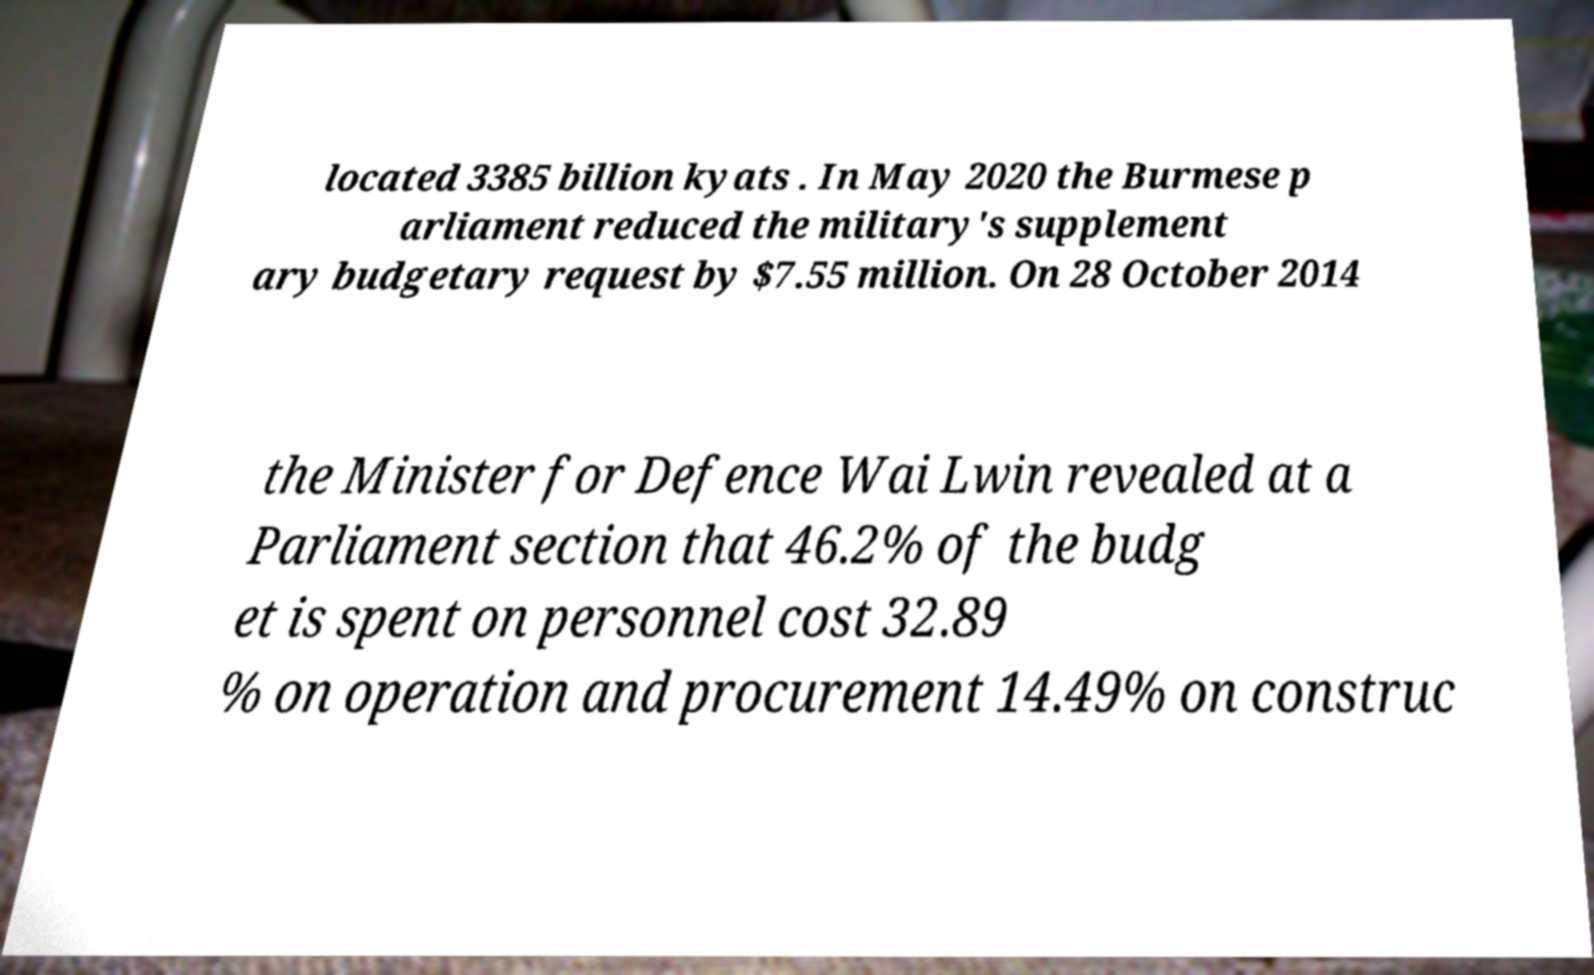What messages or text are displayed in this image? I need them in a readable, typed format. located 3385 billion kyats . In May 2020 the Burmese p arliament reduced the military's supplement ary budgetary request by $7.55 million. On 28 October 2014 the Minister for Defence Wai Lwin revealed at a Parliament section that 46.2% of the budg et is spent on personnel cost 32.89 % on operation and procurement 14.49% on construc 